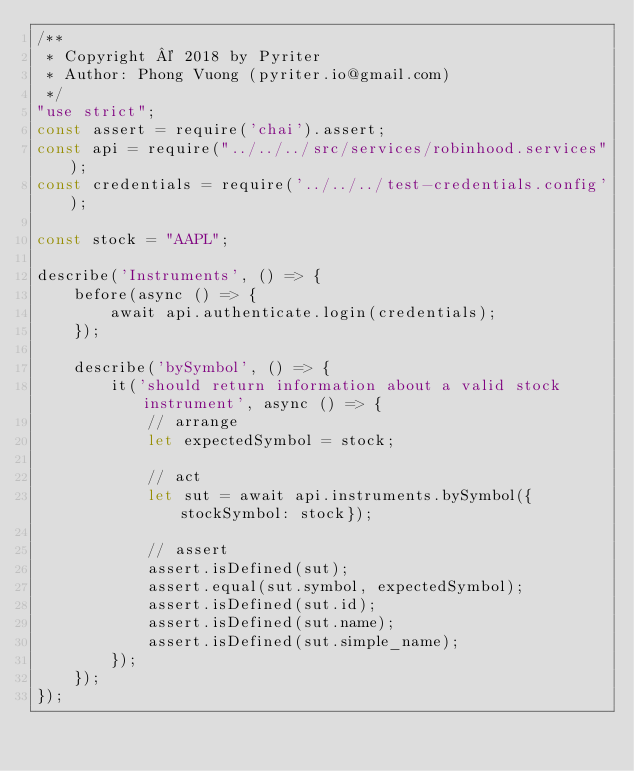Convert code to text. <code><loc_0><loc_0><loc_500><loc_500><_JavaScript_>/**
 * Copyright © 2018 by Pyriter
 * Author: Phong Vuong (pyriter.io@gmail.com)
 */
"use strict";
const assert = require('chai').assert;
const api = require("../../../src/services/robinhood.services");
const credentials = require('../../../test-credentials.config');

const stock = "AAPL";

describe('Instruments', () => {
    before(async () => {
        await api.authenticate.login(credentials);
    });

    describe('bySymbol', () => {
        it('should return information about a valid stock instrument', async () => {
            // arrange
            let expectedSymbol = stock;

            // act
            let sut = await api.instruments.bySymbol({stockSymbol: stock});

            // assert
            assert.isDefined(sut);
            assert.equal(sut.symbol, expectedSymbol);
            assert.isDefined(sut.id);
            assert.isDefined(sut.name);
            assert.isDefined(sut.simple_name);
        });
    });
});
</code> 